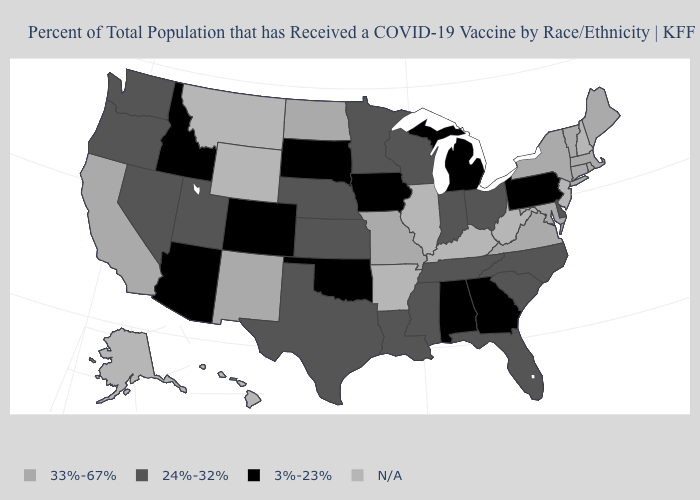What is the value of Ohio?
Quick response, please. 24%-32%. Name the states that have a value in the range 24%-32%?
Give a very brief answer. Delaware, Florida, Indiana, Kansas, Louisiana, Minnesota, Mississippi, Nebraska, Nevada, North Carolina, Ohio, Oregon, South Carolina, Tennessee, Texas, Utah, Washington, Wisconsin. Does the first symbol in the legend represent the smallest category?
Quick response, please. No. What is the value of Arkansas?
Write a very short answer. N/A. How many symbols are there in the legend?
Keep it brief. 4. Does Iowa have the highest value in the MidWest?
Be succinct. No. Does Oklahoma have the lowest value in the USA?
Give a very brief answer. Yes. What is the lowest value in states that border Pennsylvania?
Concise answer only. 24%-32%. Among the states that border North Dakota , which have the lowest value?
Be succinct. South Dakota. Which states have the lowest value in the West?
Be succinct. Arizona, Colorado, Idaho. Name the states that have a value in the range 33%-67%?
Answer briefly. California, Connecticut, Maine, Maryland, Massachusetts, Missouri, New Mexico, New York, North Dakota, Rhode Island, Vermont, Virginia. Does Arizona have the lowest value in the West?
Short answer required. Yes. Name the states that have a value in the range 3%-23%?
Concise answer only. Alabama, Arizona, Colorado, Georgia, Idaho, Iowa, Michigan, Oklahoma, Pennsylvania, South Dakota. Name the states that have a value in the range 33%-67%?
Be succinct. California, Connecticut, Maine, Maryland, Massachusetts, Missouri, New Mexico, New York, North Dakota, Rhode Island, Vermont, Virginia. 